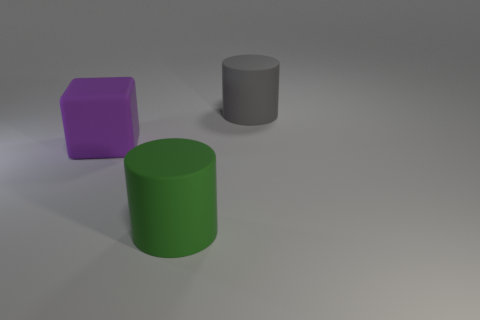Subtract all green cylinders. How many cylinders are left? 1 Add 3 cyan spheres. How many cyan spheres exist? 3 Add 3 rubber things. How many objects exist? 6 Subtract 0 green blocks. How many objects are left? 3 Subtract all cylinders. How many objects are left? 1 Subtract 2 cylinders. How many cylinders are left? 0 Subtract all blue blocks. Subtract all red cylinders. How many blocks are left? 1 Subtract all blue blocks. How many green cylinders are left? 1 Subtract all gray cylinders. Subtract all rubber cubes. How many objects are left? 1 Add 3 large gray matte cylinders. How many large gray matte cylinders are left? 4 